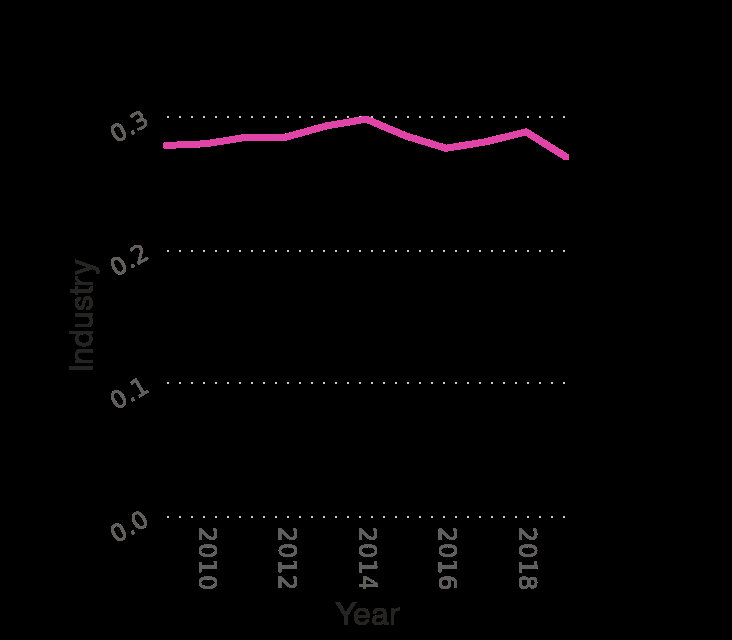<image>
What is the maximum value on the y-axis? The maximum value on the y-axis is 0.3. How did the number of industries in the GDP change between 2014 and 2019? The information provided does not mention any change in the number of industries in the GDP between 2014 and 2019. What was the share of industries in the GDP in 2009?  The exact share of industries in the GDP in 2009 is not mentioned in the given information. 